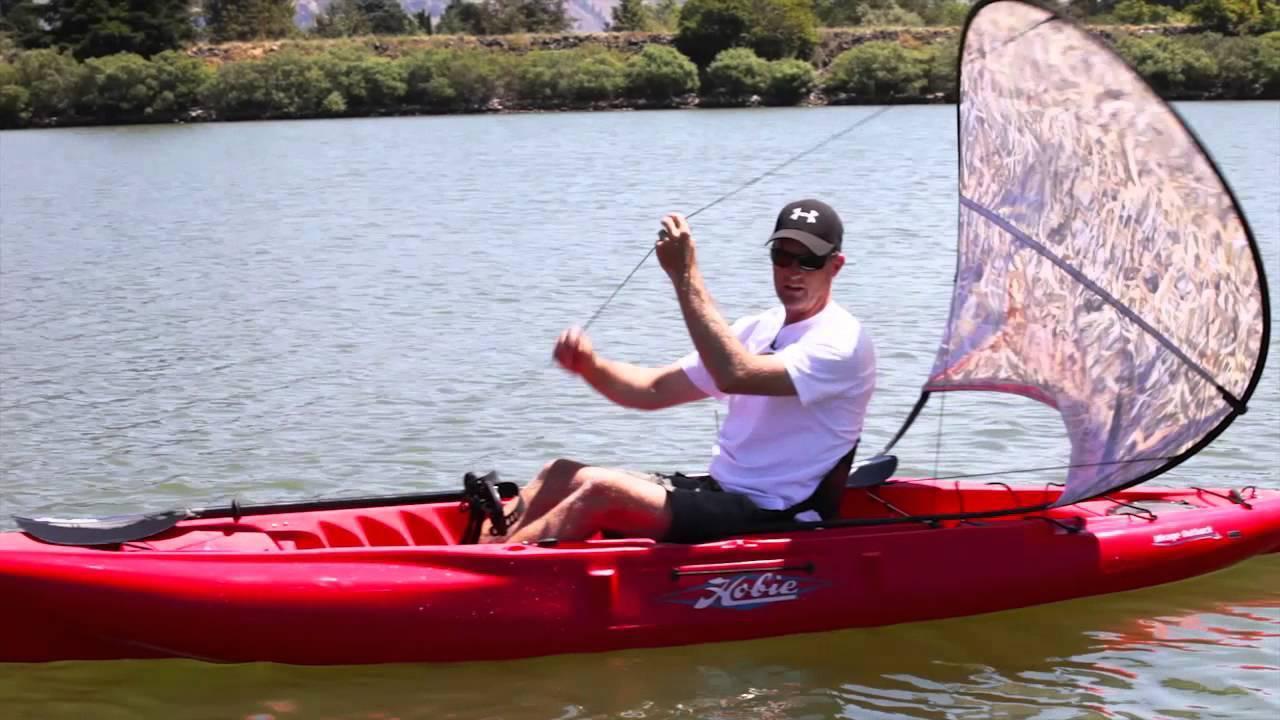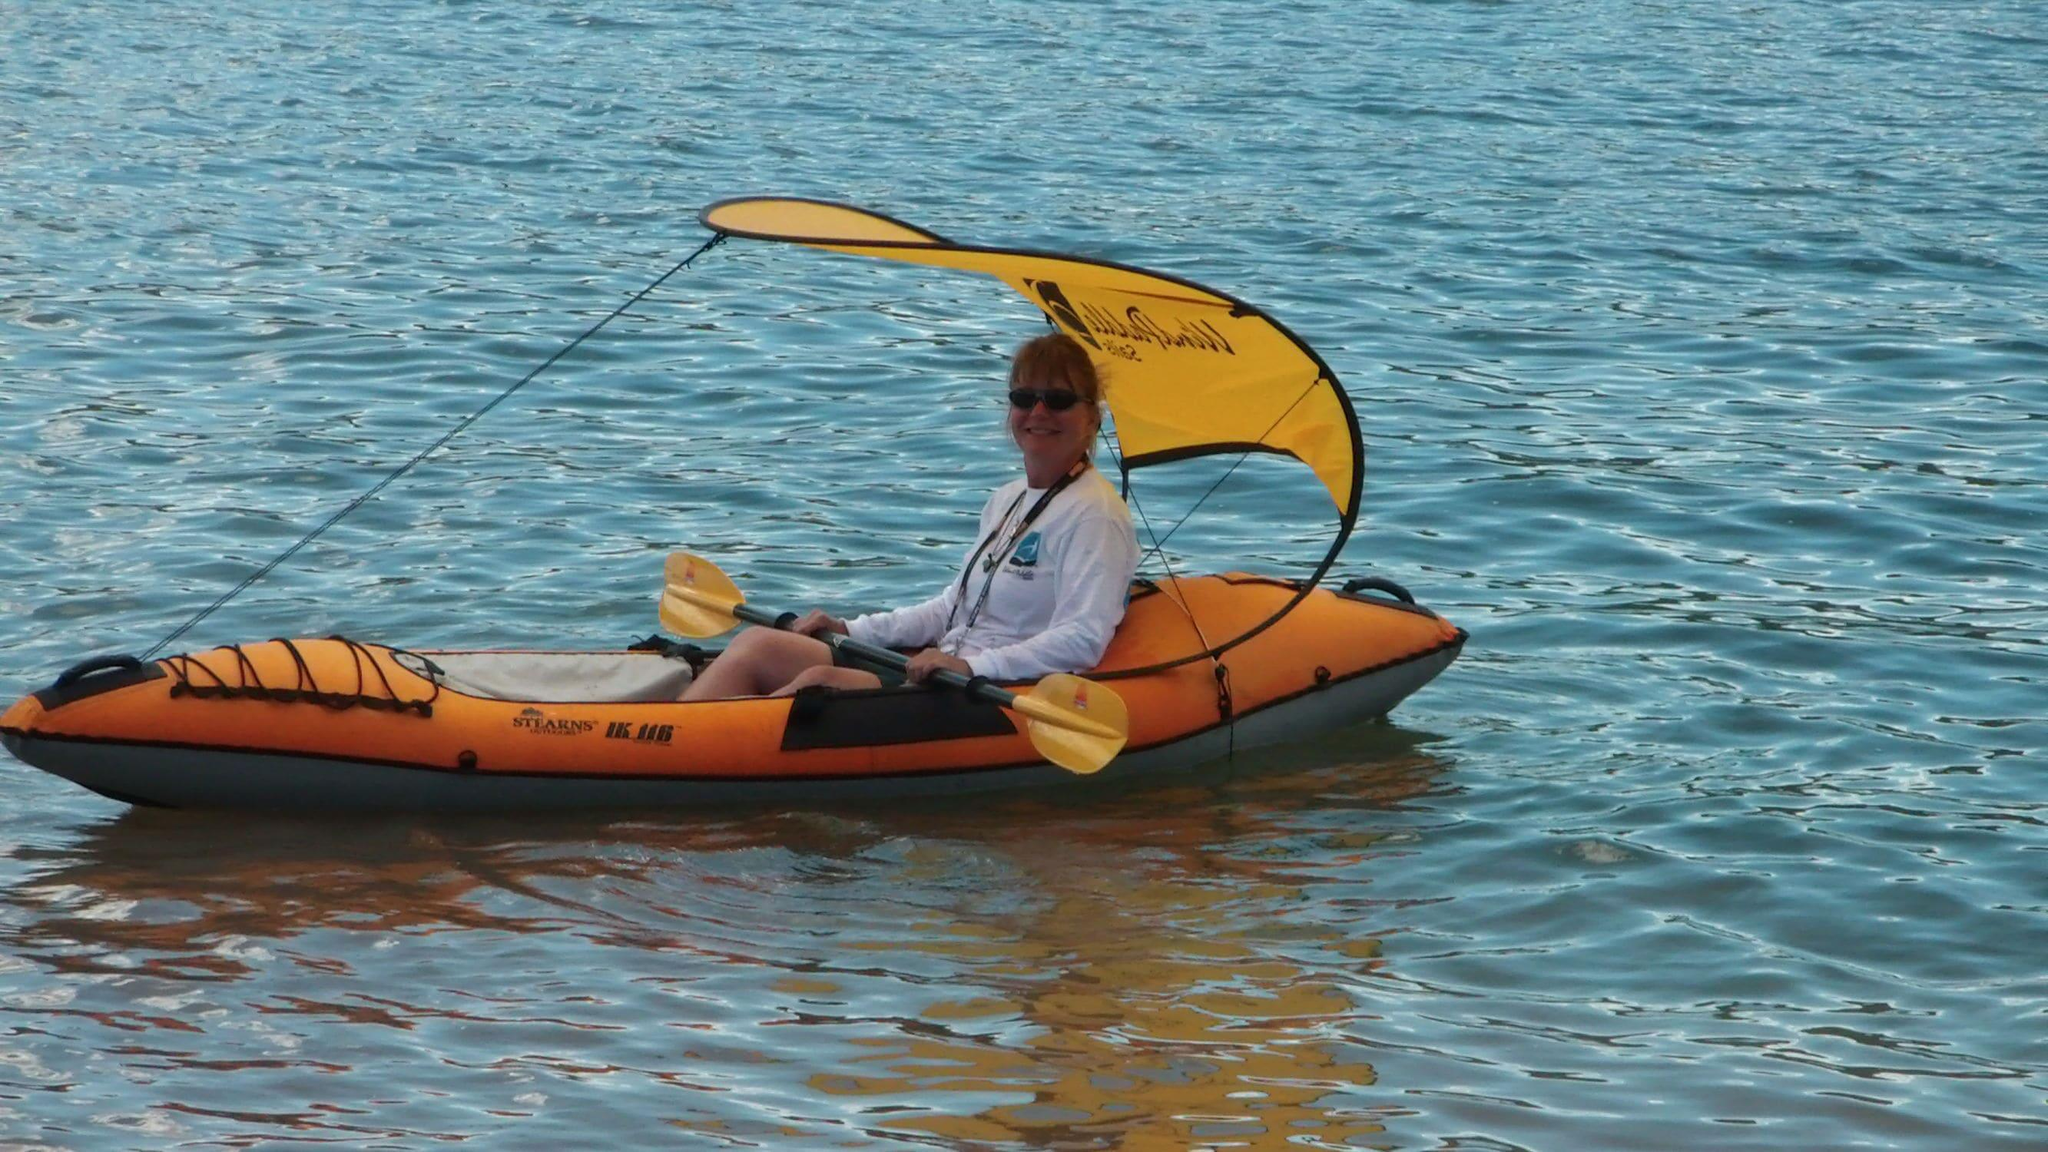The first image is the image on the left, the second image is the image on the right. Evaluate the accuracy of this statement regarding the images: "There is a red canoe in water in the left image.". Is it true? Answer yes or no. Yes. 